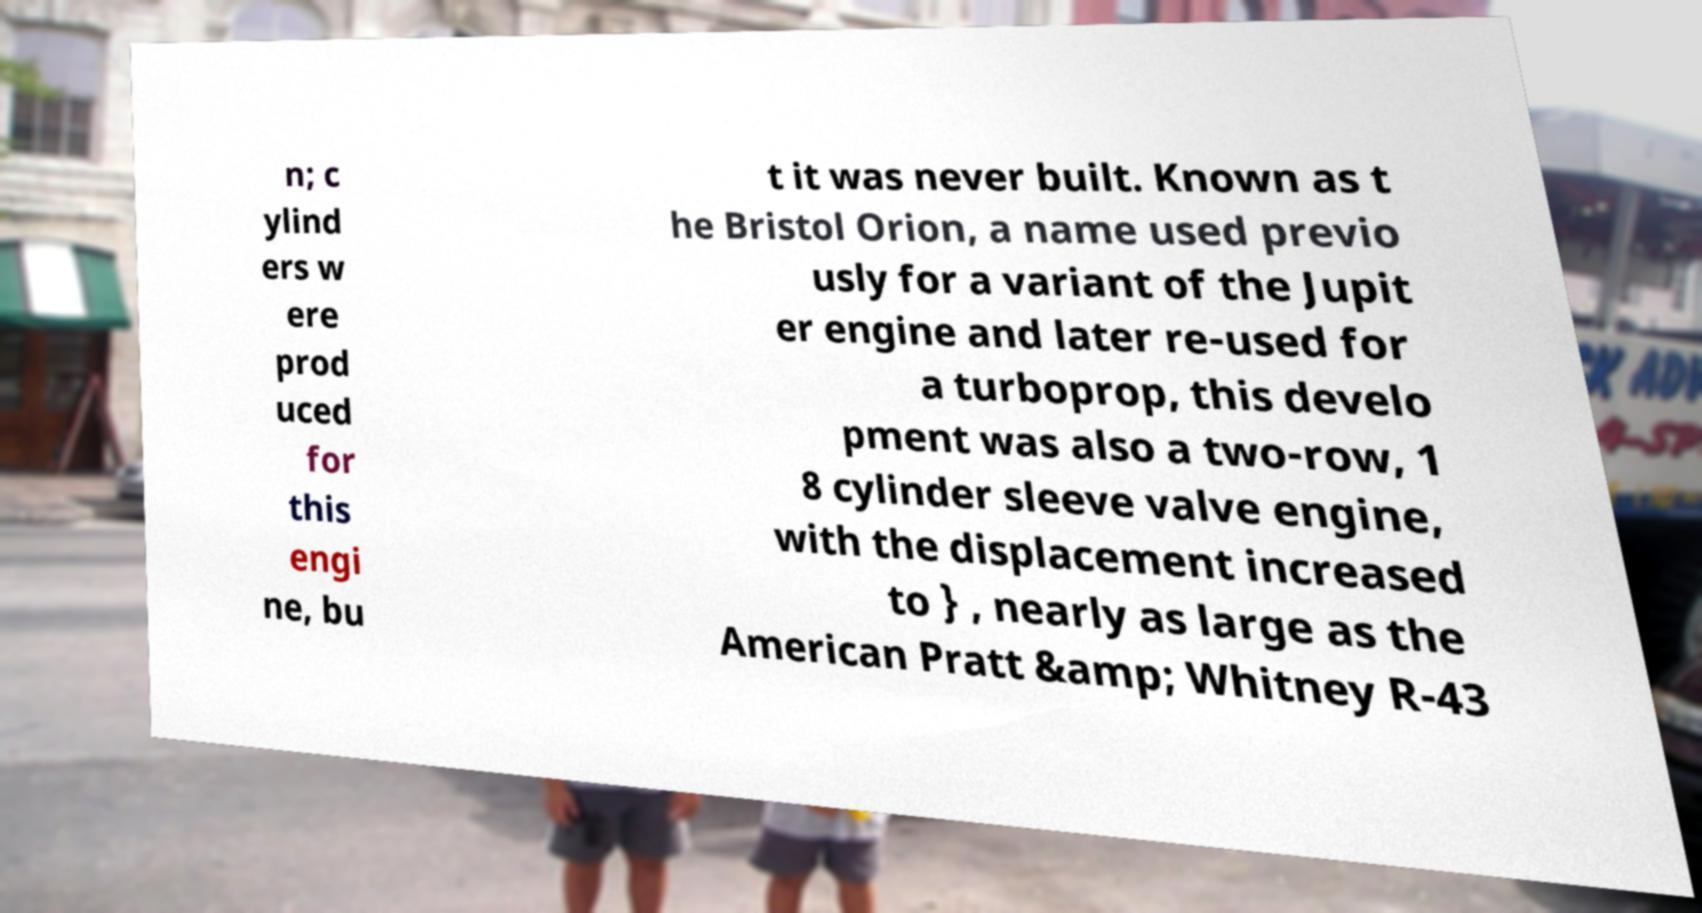Please read and relay the text visible in this image. What does it say? n; c ylind ers w ere prod uced for this engi ne, bu t it was never built. Known as t he Bristol Orion, a name used previo usly for a variant of the Jupit er engine and later re-used for a turboprop, this develo pment was also a two-row, 1 8 cylinder sleeve valve engine, with the displacement increased to } , nearly as large as the American Pratt &amp; Whitney R-43 